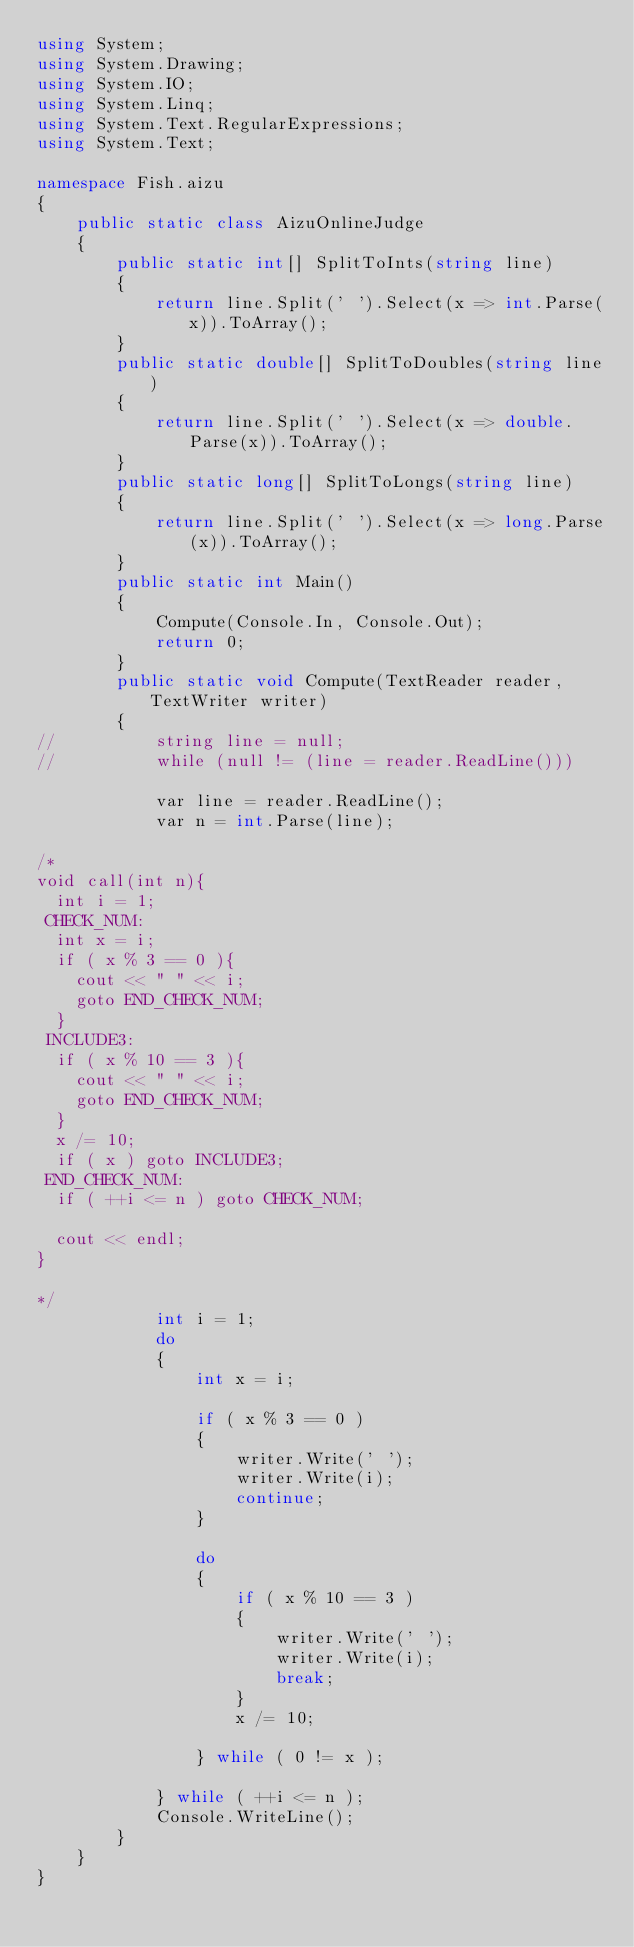<code> <loc_0><loc_0><loc_500><loc_500><_C#_>using System;
using System.Drawing;
using System.IO;
using System.Linq;
using System.Text.RegularExpressions;
using System.Text;

namespace Fish.aizu
{
	public static class AizuOnlineJudge
	{
		public static int[] SplitToInts(string line)
		{
			return line.Split(' ').Select(x => int.Parse(x)).ToArray();
		}
		public static double[] SplitToDoubles(string line)
		{
			return line.Split(' ').Select(x => double.Parse(x)).ToArray();
		}
		public static long[] SplitToLongs(string line)
		{
			return line.Split(' ').Select(x => long.Parse(x)).ToArray();
		}
		public static int Main()
		{
			Compute(Console.In, Console.Out);
			return 0;
		}
		public static void Compute(TextReader reader, TextWriter writer)
		{
//			string line = null;
//			while (null != (line = reader.ReadLine()))

			var line = reader.ReadLine();
			var n = int.Parse(line);
			
/*
void call(int n){
  int i = 1;
 CHECK_NUM:
  int x = i;
  if ( x % 3 == 0 ){
    cout << " " << i;
    goto END_CHECK_NUM;
  }
 INCLUDE3:
  if ( x % 10 == 3 ){
    cout << " " << i;
    goto END_CHECK_NUM;
  }
  x /= 10;
  if ( x ) goto INCLUDE3;
 END_CHECK_NUM:
  if ( ++i <= n ) goto CHECK_NUM;

  cout << endl;
}

*/			
			int i = 1;
			do
			{
				int x = i;
				
				if ( x % 3 == 0 )
				{
					writer.Write(' ');
					writer.Write(i);
					continue;
				}
				
				do
				{
					if ( x % 10 == 3 )
					{
						writer.Write(' ');
						writer.Write(i);
						break;
					}
					x /= 10;
				
				} while ( 0 != x );
				
			} while ( ++i <= n );
			Console.WriteLine();
		}
	}
}</code> 